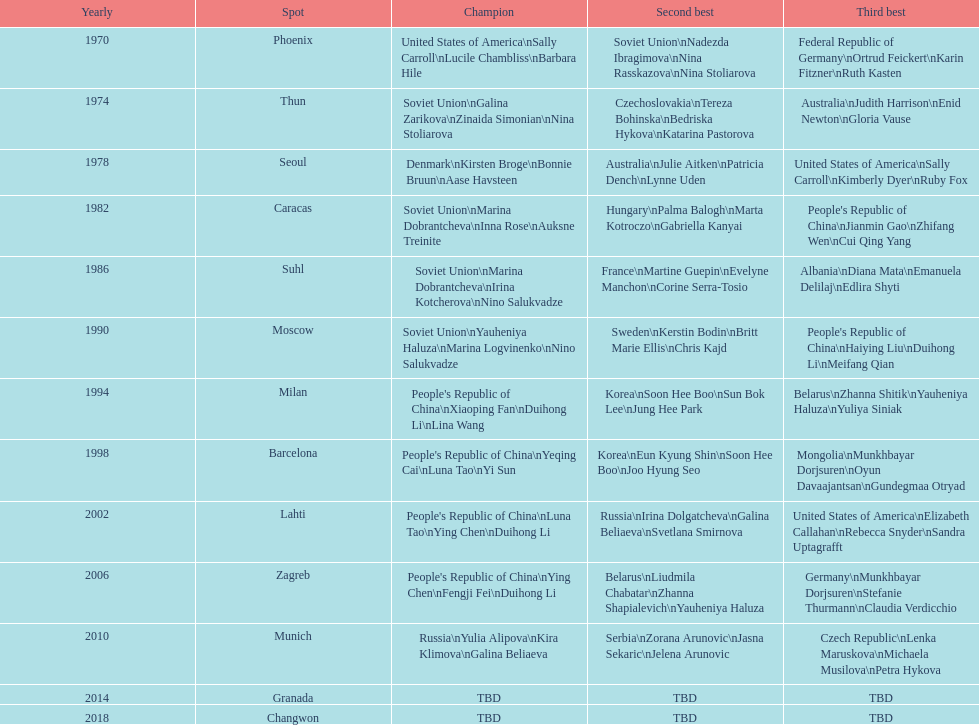Whose name is listed before bonnie bruun's in the gold column? Kirsten Broge. 